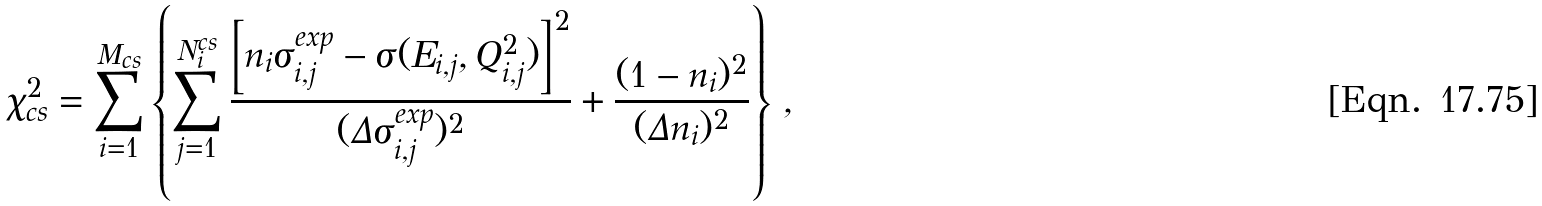<formula> <loc_0><loc_0><loc_500><loc_500>\chi ^ { 2 } _ { \text {cs} } = \sum _ { i = 1 } ^ { M _ { \text {cs} } } \left \{ \sum _ { j = 1 } ^ { N ^ { \text {cs} } _ { i } } \frac { \left [ n _ { i } \sigma _ { i , j } ^ { \text {exp} } - \sigma ( E _ { i , j } , Q _ { i , j } ^ { 2 } ) \right ] ^ { 2 } } { ( \Delta \sigma _ { i , j } ^ { \text {exp} } ) ^ { 2 } } + \frac { ( 1 - n _ { i } ) ^ { 2 } } { ( \Delta n _ { i } ) ^ { 2 } } \right \} \, ,</formula> 